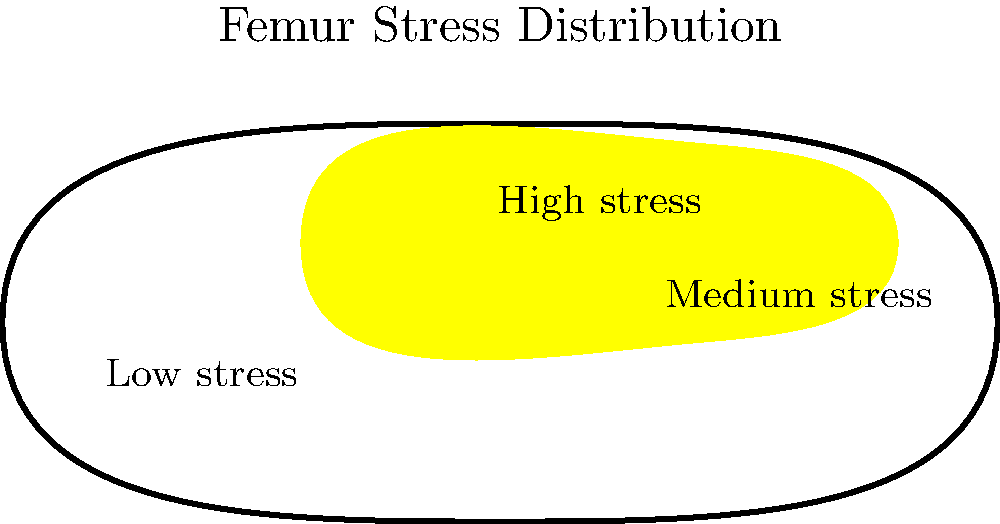Considering the stress distribution in the femur bone shown above, which area is most likely to experience data-sensitive microstructural changes under prolonged high-stress conditions, potentially raising privacy concerns in long-term medical monitoring? To answer this question, we need to analyze the stress distribution in the femur bone and consider its implications for data protection and privacy:

1. Observe the color-coded stress map:
   - Red area: High stress
   - Yellow area: Medium stress
   - Remaining area: Low stress

2. Identify the area of highest stress:
   The red region in the central part of the femur experiences the highest stress.

3. Understand the impact of high stress on bone microstructure:
   Prolonged high stress can lead to microstructural changes in the bone, including:
   - Increased bone remodeling
   - Changes in bone density
   - Potential microfractures

4. Consider the data sensitivity of these changes:
   Microstructural changes can be detected through various imaging techniques, potentially revealing:
   - Individual's activity levels
   - Occupational stress
   - Long-term health conditions

5. Analyze privacy implications:
   - Detailed bone microstructure data could be used to identify individuals
   - Long-term monitoring of these changes might reveal sensitive information about a person's lifestyle and health

6. Data protection concerns:
   The high-stress area would require the most frequent monitoring, generating more data and thus presenting a higher risk for potential privacy breaches.

Therefore, the red high-stress area in the central part of the femur is most likely to experience data-sensitive microstructural changes and raise privacy concerns in long-term medical monitoring.
Answer: The high-stress (red) area in the central femur 